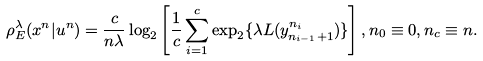<formula> <loc_0><loc_0><loc_500><loc_500>\rho _ { E } ^ { \lambda } ( x ^ { n } | u ^ { n } ) = \frac { c } { n \lambda } \log _ { 2 } \left [ \frac { 1 } { c } \sum _ { i = 1 } ^ { c } \exp _ { 2 } \{ \lambda L ( y _ { n _ { i - 1 } + 1 } ^ { n _ { i } } ) \} \right ] , n _ { 0 } \equiv 0 , n _ { c } \equiv n .</formula> 